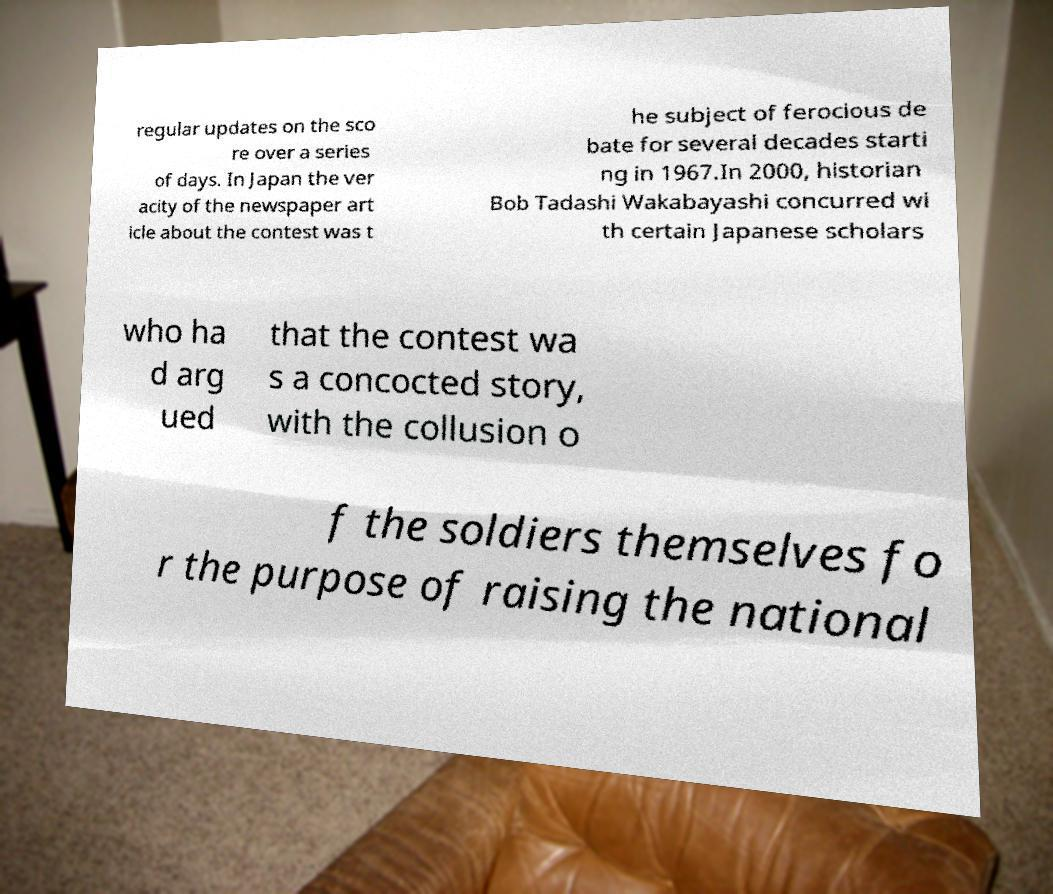Please read and relay the text visible in this image. What does it say? regular updates on the sco re over a series of days. In Japan the ver acity of the newspaper art icle about the contest was t he subject of ferocious de bate for several decades starti ng in 1967.In 2000, historian Bob Tadashi Wakabayashi concurred wi th certain Japanese scholars who ha d arg ued that the contest wa s a concocted story, with the collusion o f the soldiers themselves fo r the purpose of raising the national 